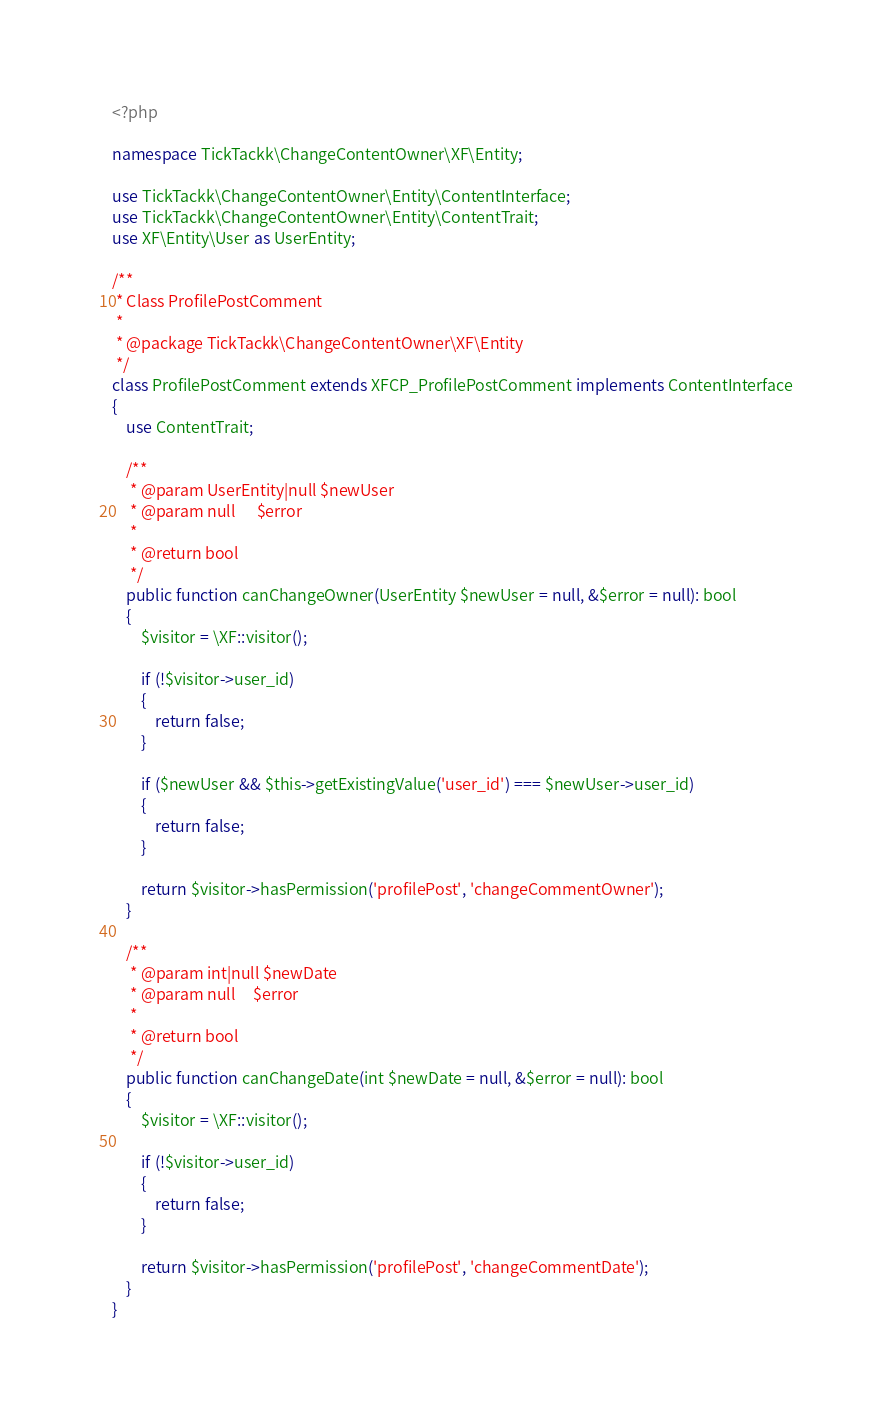Convert code to text. <code><loc_0><loc_0><loc_500><loc_500><_PHP_><?php

namespace TickTackk\ChangeContentOwner\XF\Entity;

use TickTackk\ChangeContentOwner\Entity\ContentInterface;
use TickTackk\ChangeContentOwner\Entity\ContentTrait;
use XF\Entity\User as UserEntity;

/**
 * Class ProfilePostComment
 *
 * @package TickTackk\ChangeContentOwner\XF\Entity
 */
class ProfilePostComment extends XFCP_ProfilePostComment implements ContentInterface
{
    use ContentTrait;

    /**
     * @param UserEntity|null $newUser
     * @param null      $error
     *
     * @return bool
     */
    public function canChangeOwner(UserEntity $newUser = null, &$error = null): bool
    {
        $visitor = \XF::visitor();

        if (!$visitor->user_id)
        {
            return false;
        }

        if ($newUser && $this->getExistingValue('user_id') === $newUser->user_id)
        {
            return false;
        }

        return $visitor->hasPermission('profilePost', 'changeCommentOwner');
    }

    /**
     * @param int|null $newDate
     * @param null     $error
     *
     * @return bool
     */
    public function canChangeDate(int $newDate = null, &$error = null): bool
    {
        $visitor = \XF::visitor();

        if (!$visitor->user_id)
        {
            return false;
        }

        return $visitor->hasPermission('profilePost', 'changeCommentDate');
    }
}</code> 